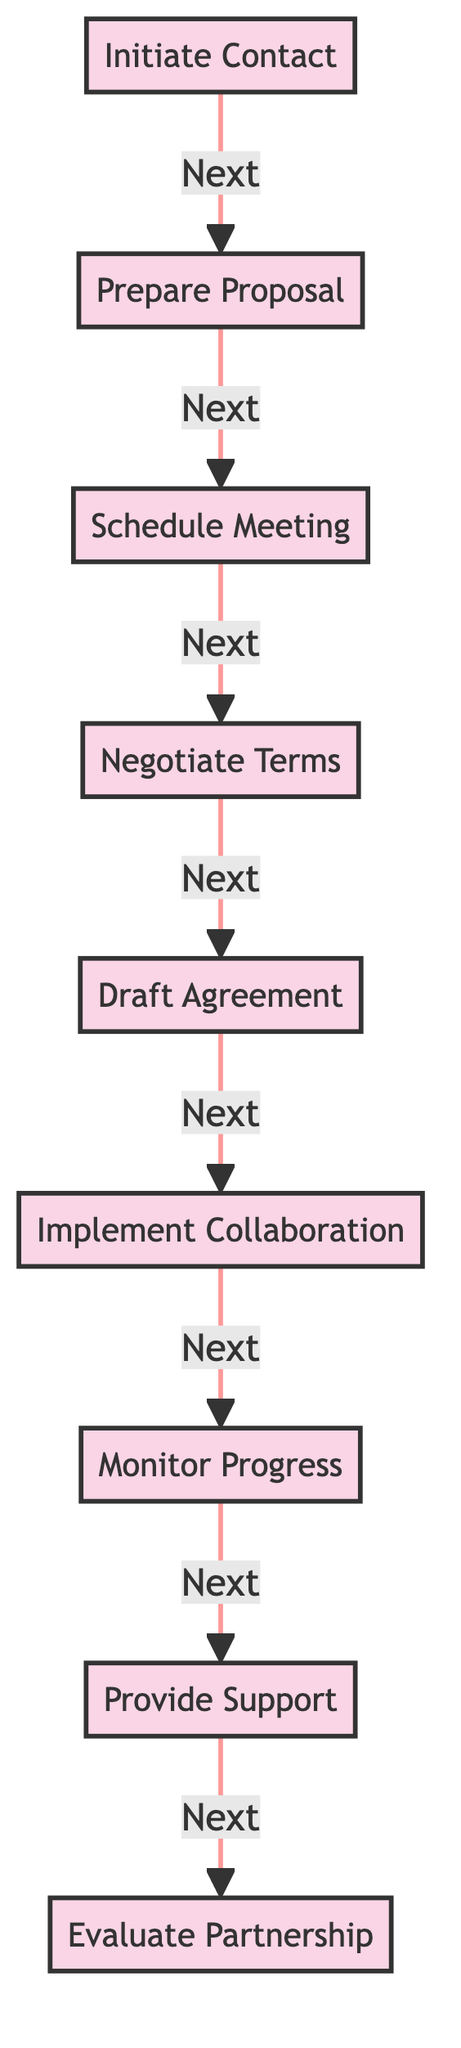What is the first step in the partnership development flow? The first step in the flow is represented by the node labeled "Initiate Contact," which indicates that reaching out to potential partners is the initial action.
Answer: Initiate Contact How many nodes are present in the diagram? By counting the labeled nodes in the diagram, we find there are a total of nine nodes representing different steps in the partnership development process.
Answer: 9 What is the final step in the collaboration process? The last node in the flow is labeled "Evaluate Partnership," which signifies that assessing the effectiveness of the partnership is the concluding action.
Answer: Evaluate Partnership Which step comes immediately after "Draft Agreement"? From the flow direction indicated by the edges, "Implement Collaboration" is the next step that follows "Draft Agreement."
Answer: Implement Collaboration What is the relationship between "Monitor Progress" and "Provide Support"? The diagram shows a directed edge from "Monitor Progress" to "Provide Support," indicating that monitoring is a prerequisite for providing ongoing support in the collaboration process.
Answer: Next What processes are involved after preparing the proposal? Following "Prepare Proposal," the processes include "Schedule Meeting," "Negotiate Terms," and "Draft Agreement," indicating a sequence of actions that must take place after the proposal is prepared.
Answer: Schedule Meeting, Negotiate Terms, Draft Agreement How many directed edges connect the steps in the process? The diagram shows eight directed edges that connect the different steps, representing the flow from one step to the next throughout the partnership development process.
Answer: 8 What is the common objective of "Provide Support" and "Monitor Progress"? Both "Provide Support" and "Monitor Progress" aim at ensuring the effectiveness and success of the partnership, indicating their roles in ongoing collaboration after the initial implementation.
Answer: Ongoing Collaboration 